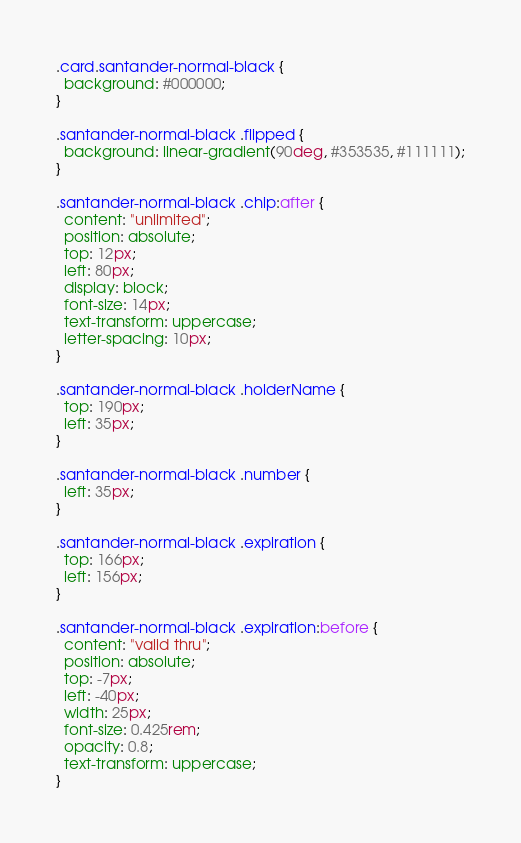Convert code to text. <code><loc_0><loc_0><loc_500><loc_500><_CSS_>.card.santander-normal-black {
  background: #000000;
}

.santander-normal-black .flipped {
  background: linear-gradient(90deg, #353535, #111111);
}

.santander-normal-black .chip:after {
  content: "unlimited";
  position: absolute;
  top: 12px;
  left: 80px;
  display: block;
  font-size: 14px;
  text-transform: uppercase;
  letter-spacing: 10px;
}

.santander-normal-black .holderName {
  top: 190px;
  left: 35px;
}

.santander-normal-black .number {
  left: 35px;
}

.santander-normal-black .expiration {
  top: 166px;
  left: 156px;
}

.santander-normal-black .expiration:before {
  content: "valid thru";
  position: absolute;
  top: -7px;
  left: -40px;
  width: 25px;
  font-size: 0.425rem;
  opacity: 0.8;
  text-transform: uppercase;
}
</code> 